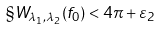<formula> <loc_0><loc_0><loc_500><loc_500>\S W _ { \lambda _ { 1 } , \lambda _ { 2 } } ( f _ { 0 } ) < 4 \pi + \varepsilon _ { 2 }</formula> 